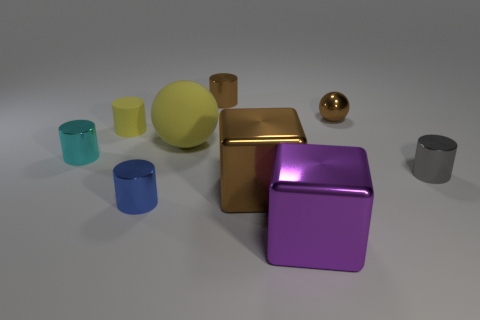There is a small metal cylinder that is behind the matte thing on the right side of the tiny yellow object; are there any small gray metal cylinders that are on the right side of it?
Offer a terse response. Yes. How many brown metal blocks are there?
Your answer should be very brief. 1. What number of objects are things on the left side of the purple metal thing or things in front of the gray cylinder?
Your response must be concise. 7. Is the size of the metallic cylinder in front of the gray object the same as the tiny brown cylinder?
Your answer should be compact. Yes. There is another object that is the same shape as the big brown metal object; what size is it?
Your response must be concise. Large. What is the material of the yellow thing that is the same size as the shiny ball?
Your response must be concise. Rubber. What material is the yellow thing that is the same shape as the small gray thing?
Offer a terse response. Rubber. What number of other objects are the same size as the yellow cylinder?
Provide a short and direct response. 5. There is a shiny block that is the same color as the metal ball; what is its size?
Provide a short and direct response. Large. How many small cylinders are the same color as the large rubber object?
Your answer should be compact. 1. 